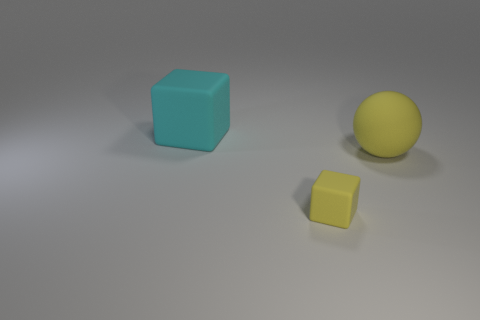Add 1 spheres. How many objects exist? 4 Subtract all balls. How many objects are left? 2 Add 2 big purple metallic cubes. How many big purple metallic cubes exist? 2 Subtract 0 cyan balls. How many objects are left? 3 Subtract all shiny things. Subtract all yellow spheres. How many objects are left? 2 Add 3 tiny yellow matte things. How many tiny yellow matte things are left? 4 